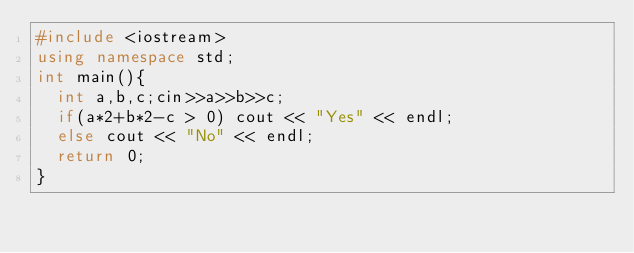Convert code to text. <code><loc_0><loc_0><loc_500><loc_500><_C++_>#include <iostream>
using namespace std;
int main(){
  int a,b,c;cin>>a>>b>>c;
  if(a*2+b*2-c > 0) cout << "Yes" << endl;
  else cout << "No" << endl;
  return 0;
}
</code> 